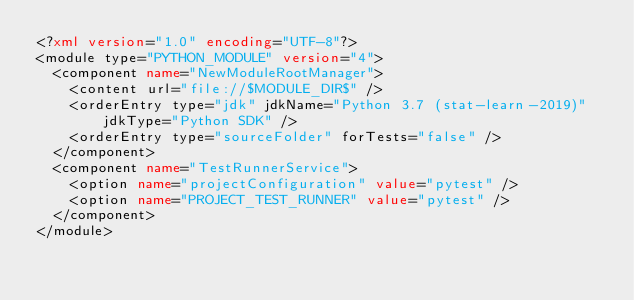Convert code to text. <code><loc_0><loc_0><loc_500><loc_500><_XML_><?xml version="1.0" encoding="UTF-8"?>
<module type="PYTHON_MODULE" version="4">
  <component name="NewModuleRootManager">
    <content url="file://$MODULE_DIR$" />
    <orderEntry type="jdk" jdkName="Python 3.7 (stat-learn-2019)" jdkType="Python SDK" />
    <orderEntry type="sourceFolder" forTests="false" />
  </component>
  <component name="TestRunnerService">
    <option name="projectConfiguration" value="pytest" />
    <option name="PROJECT_TEST_RUNNER" value="pytest" />
  </component>
</module></code> 